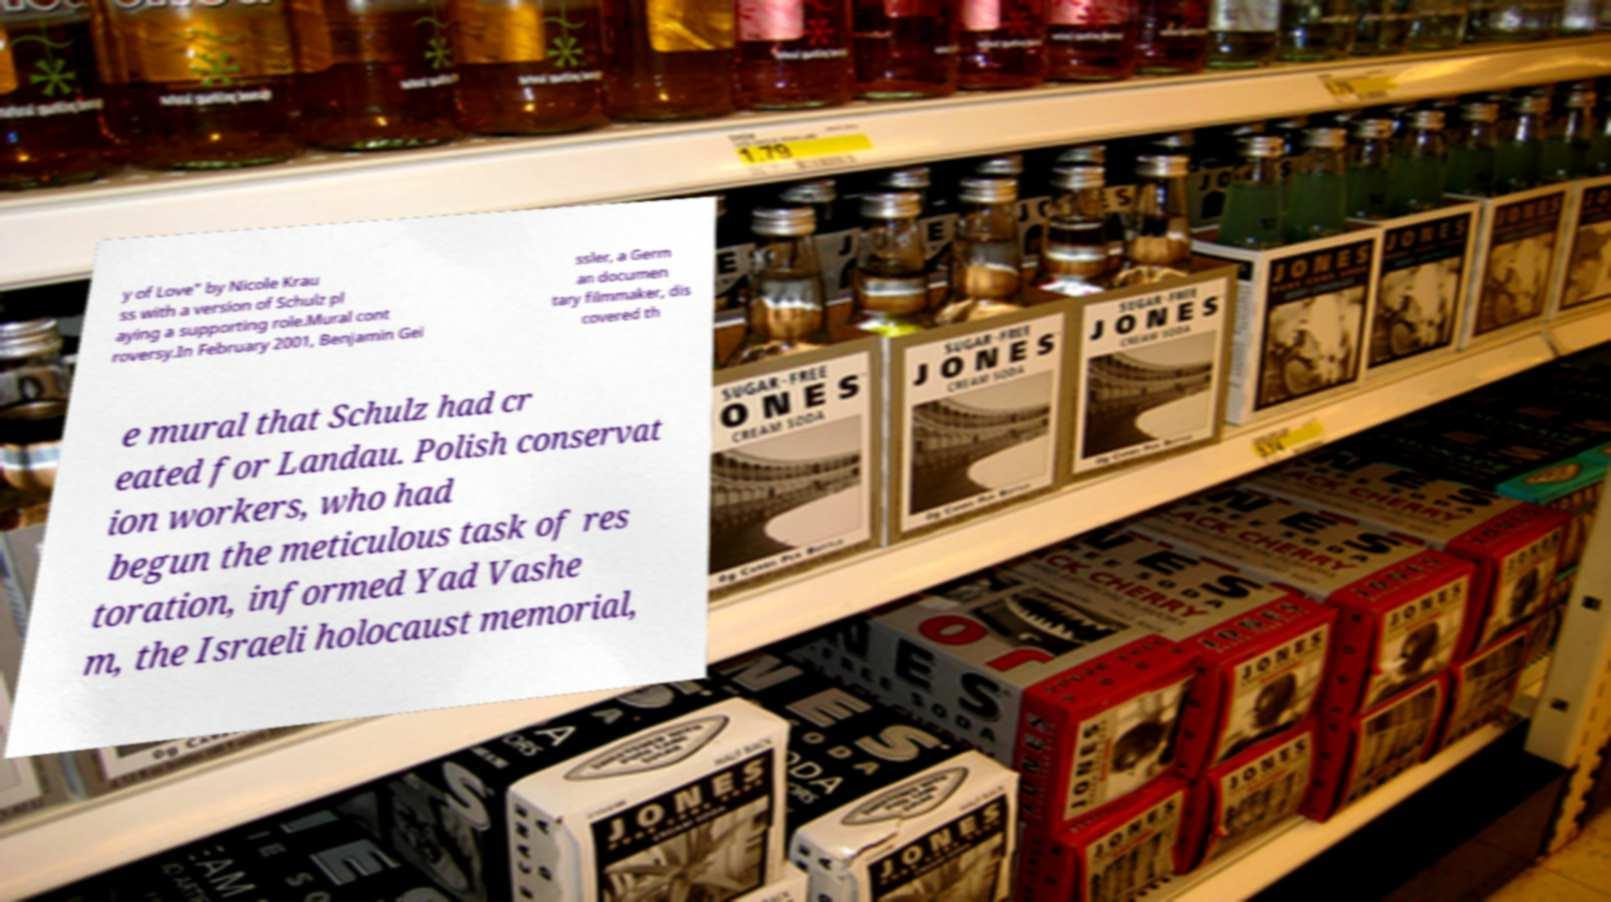What messages or text are displayed in this image? I need them in a readable, typed format. y of Love" by Nicole Krau ss with a version of Schulz pl aying a supporting role.Mural cont roversy.In February 2001, Benjamin Gei ssler, a Germ an documen tary filmmaker, dis covered th e mural that Schulz had cr eated for Landau. Polish conservat ion workers, who had begun the meticulous task of res toration, informed Yad Vashe m, the Israeli holocaust memorial, 